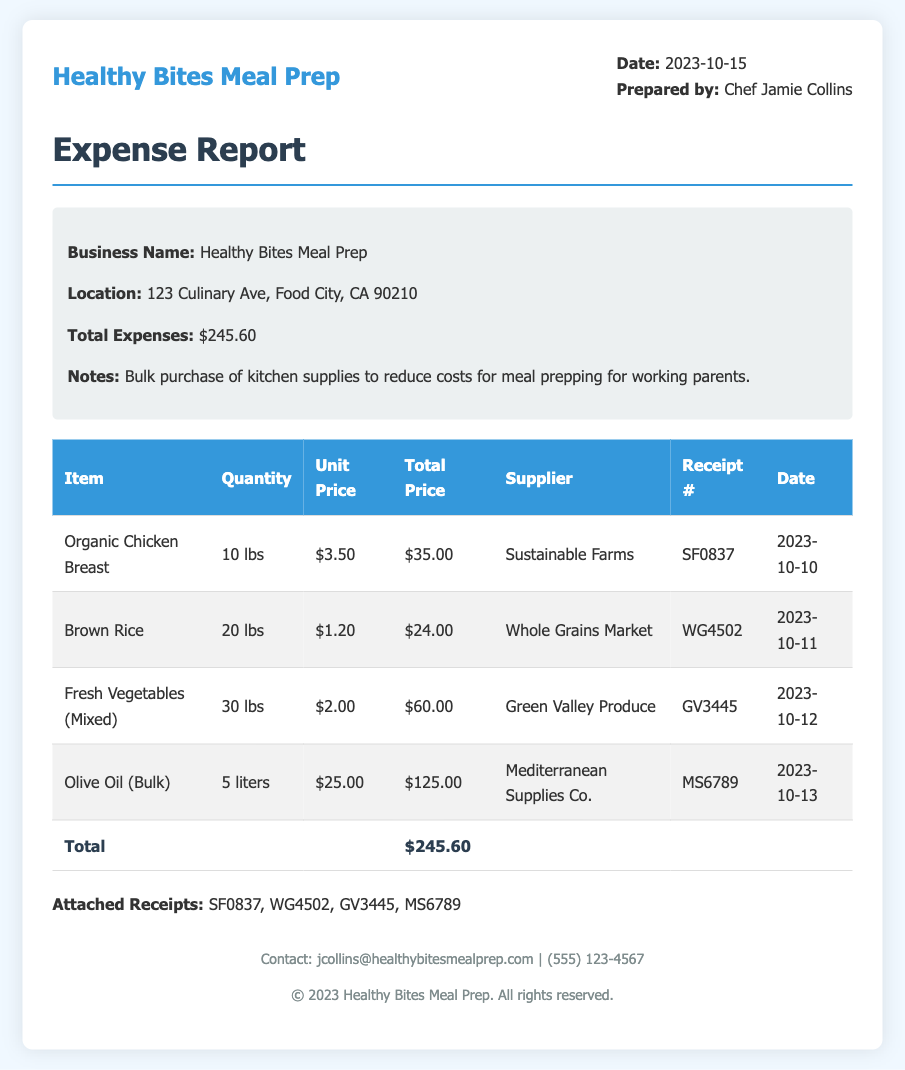What is the total expense amount? The total expenses listed in the document sum up to $245.60.
Answer: $245.60 Who prepared the expense report? The report specifies that Chef Jamie Collins prepared the expense report.
Answer: Chef Jamie Collins What is the date of the expense report? The document indicates that the expense report was prepared on 2023-10-15.
Answer: 2023-10-15 What supplier provided the olive oil? The document mentions that Mediterranean Supplies Co. is the supplier for the olive oil.
Answer: Mediterranean Supplies Co How many pounds of fresh vegetables were purchased? The report states that 30 lbs of fresh vegetables were bought.
Answer: 30 lbs What was the unit price for brown rice? The expense report shows that the unit price for brown rice is $1.20.
Answer: $1.20 What is the receipt number for the organic chicken breast? The document lists SF0837 as the receipt number for the organic chicken breast.
Answer: SF0837 What item accounts for the highest total price on the report? The document shows that olive oil (bulk) accounts for the highest total price at $125.00.
Answer: Olive Oil (Bulk) How many liters of olive oil were purchased? The expense report indicates that 5 liters of olive oil were purchased.
Answer: 5 liters 